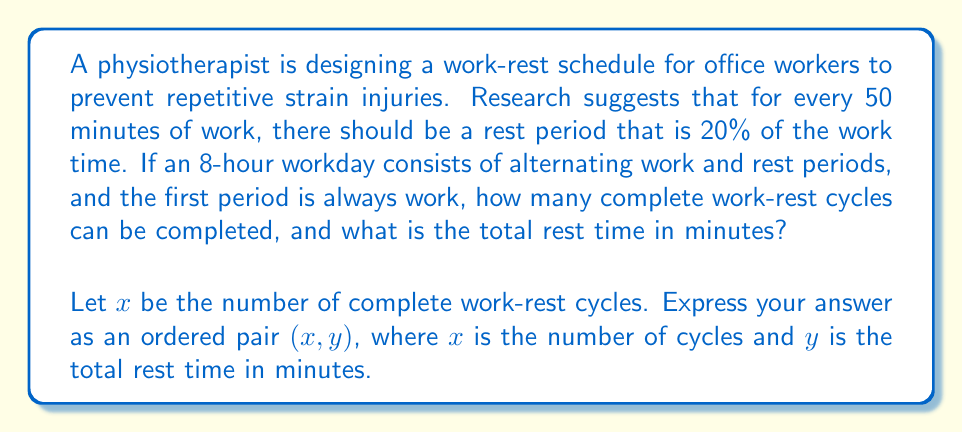Give your solution to this math problem. Let's approach this step-by-step:

1) First, let's calculate the duration of one work-rest cycle:
   Work period = 50 minutes
   Rest period = 20% of 50 minutes = 0.2 × 50 = 10 minutes
   Total cycle time = 50 + 10 = 60 minutes

2) Now, let's convert the 8-hour workday to minutes:
   8 hours = 8 × 60 = 480 minutes

3) Let $x$ be the number of complete work-rest cycles. We can set up an equation:
   $$60x \leq 480$$

4) Solving for $x$:
   $$x \leq 8$$

   Since $x$ must be a whole number, the maximum number of complete cycles is 7.

5) Now, let's calculate the total time used by 7 complete cycles:
   7 × 60 = 420 minutes

6) This leaves 60 minutes at the end of the day for an additional work period.

7) To calculate the total rest time:
   Rest time per cycle = 10 minutes
   Total rest time = 7 × 10 = 70 minutes

Therefore, there are 7 complete work-rest cycles, and the total rest time is 70 minutes.
Answer: $(7, 70)$ 